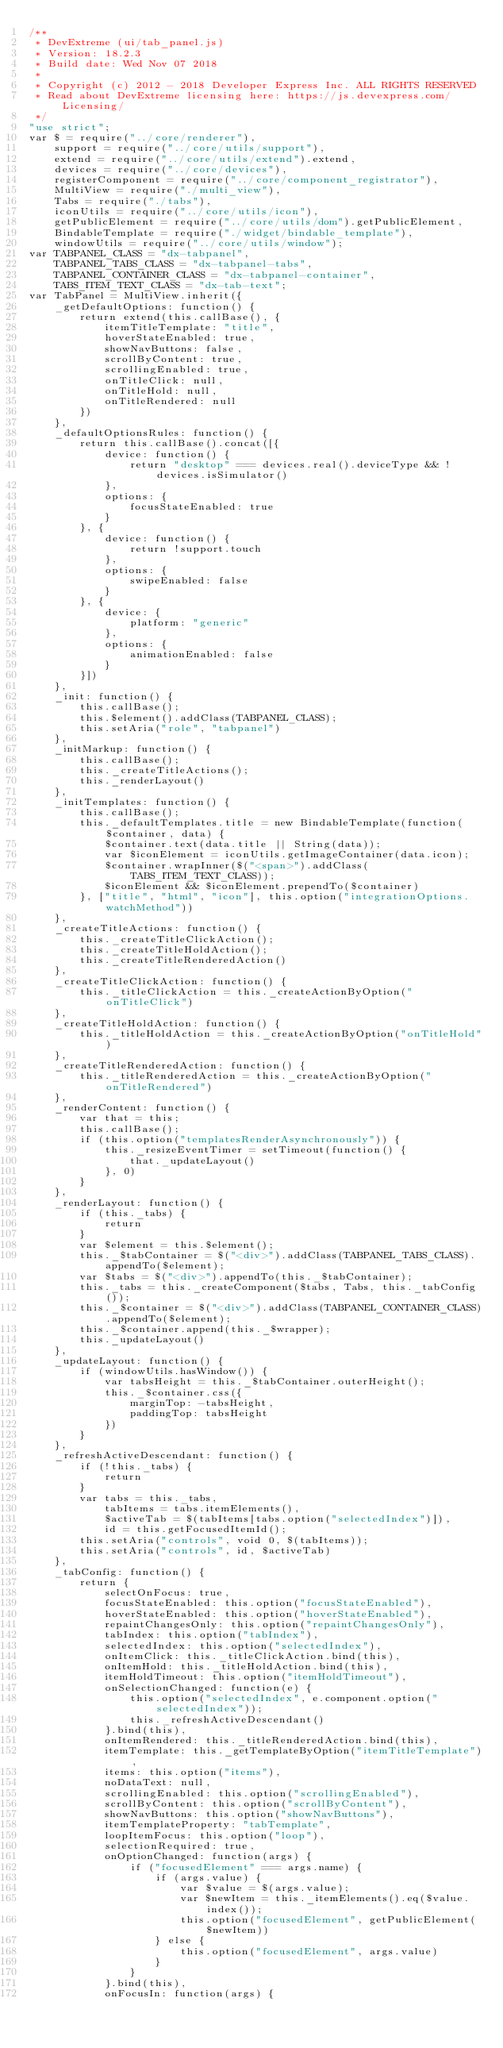Convert code to text. <code><loc_0><loc_0><loc_500><loc_500><_JavaScript_>/**
 * DevExtreme (ui/tab_panel.js)
 * Version: 18.2.3
 * Build date: Wed Nov 07 2018
 *
 * Copyright (c) 2012 - 2018 Developer Express Inc. ALL RIGHTS RESERVED
 * Read about DevExtreme licensing here: https://js.devexpress.com/Licensing/
 */
"use strict";
var $ = require("../core/renderer"),
    support = require("../core/utils/support"),
    extend = require("../core/utils/extend").extend,
    devices = require("../core/devices"),
    registerComponent = require("../core/component_registrator"),
    MultiView = require("./multi_view"),
    Tabs = require("./tabs"),
    iconUtils = require("../core/utils/icon"),
    getPublicElement = require("../core/utils/dom").getPublicElement,
    BindableTemplate = require("./widget/bindable_template"),
    windowUtils = require("../core/utils/window");
var TABPANEL_CLASS = "dx-tabpanel",
    TABPANEL_TABS_CLASS = "dx-tabpanel-tabs",
    TABPANEL_CONTAINER_CLASS = "dx-tabpanel-container",
    TABS_ITEM_TEXT_CLASS = "dx-tab-text";
var TabPanel = MultiView.inherit({
    _getDefaultOptions: function() {
        return extend(this.callBase(), {
            itemTitleTemplate: "title",
            hoverStateEnabled: true,
            showNavButtons: false,
            scrollByContent: true,
            scrollingEnabled: true,
            onTitleClick: null,
            onTitleHold: null,
            onTitleRendered: null
        })
    },
    _defaultOptionsRules: function() {
        return this.callBase().concat([{
            device: function() {
                return "desktop" === devices.real().deviceType && !devices.isSimulator()
            },
            options: {
                focusStateEnabled: true
            }
        }, {
            device: function() {
                return !support.touch
            },
            options: {
                swipeEnabled: false
            }
        }, {
            device: {
                platform: "generic"
            },
            options: {
                animationEnabled: false
            }
        }])
    },
    _init: function() {
        this.callBase();
        this.$element().addClass(TABPANEL_CLASS);
        this.setAria("role", "tabpanel")
    },
    _initMarkup: function() {
        this.callBase();
        this._createTitleActions();
        this._renderLayout()
    },
    _initTemplates: function() {
        this.callBase();
        this._defaultTemplates.title = new BindableTemplate(function($container, data) {
            $container.text(data.title || String(data));
            var $iconElement = iconUtils.getImageContainer(data.icon);
            $container.wrapInner($("<span>").addClass(TABS_ITEM_TEXT_CLASS));
            $iconElement && $iconElement.prependTo($container)
        }, ["title", "html", "icon"], this.option("integrationOptions.watchMethod"))
    },
    _createTitleActions: function() {
        this._createTitleClickAction();
        this._createTitleHoldAction();
        this._createTitleRenderedAction()
    },
    _createTitleClickAction: function() {
        this._titleClickAction = this._createActionByOption("onTitleClick")
    },
    _createTitleHoldAction: function() {
        this._titleHoldAction = this._createActionByOption("onTitleHold")
    },
    _createTitleRenderedAction: function() {
        this._titleRenderedAction = this._createActionByOption("onTitleRendered")
    },
    _renderContent: function() {
        var that = this;
        this.callBase();
        if (this.option("templatesRenderAsynchronously")) {
            this._resizeEventTimer = setTimeout(function() {
                that._updateLayout()
            }, 0)
        }
    },
    _renderLayout: function() {
        if (this._tabs) {
            return
        }
        var $element = this.$element();
        this._$tabContainer = $("<div>").addClass(TABPANEL_TABS_CLASS).appendTo($element);
        var $tabs = $("<div>").appendTo(this._$tabContainer);
        this._tabs = this._createComponent($tabs, Tabs, this._tabConfig());
        this._$container = $("<div>").addClass(TABPANEL_CONTAINER_CLASS).appendTo($element);
        this._$container.append(this._$wrapper);
        this._updateLayout()
    },
    _updateLayout: function() {
        if (windowUtils.hasWindow()) {
            var tabsHeight = this._$tabContainer.outerHeight();
            this._$container.css({
                marginTop: -tabsHeight,
                paddingTop: tabsHeight
            })
        }
    },
    _refreshActiveDescendant: function() {
        if (!this._tabs) {
            return
        }
        var tabs = this._tabs,
            tabItems = tabs.itemElements(),
            $activeTab = $(tabItems[tabs.option("selectedIndex")]),
            id = this.getFocusedItemId();
        this.setAria("controls", void 0, $(tabItems));
        this.setAria("controls", id, $activeTab)
    },
    _tabConfig: function() {
        return {
            selectOnFocus: true,
            focusStateEnabled: this.option("focusStateEnabled"),
            hoverStateEnabled: this.option("hoverStateEnabled"),
            repaintChangesOnly: this.option("repaintChangesOnly"),
            tabIndex: this.option("tabIndex"),
            selectedIndex: this.option("selectedIndex"),
            onItemClick: this._titleClickAction.bind(this),
            onItemHold: this._titleHoldAction.bind(this),
            itemHoldTimeout: this.option("itemHoldTimeout"),
            onSelectionChanged: function(e) {
                this.option("selectedIndex", e.component.option("selectedIndex"));
                this._refreshActiveDescendant()
            }.bind(this),
            onItemRendered: this._titleRenderedAction.bind(this),
            itemTemplate: this._getTemplateByOption("itemTitleTemplate"),
            items: this.option("items"),
            noDataText: null,
            scrollingEnabled: this.option("scrollingEnabled"),
            scrollByContent: this.option("scrollByContent"),
            showNavButtons: this.option("showNavButtons"),
            itemTemplateProperty: "tabTemplate",
            loopItemFocus: this.option("loop"),
            selectionRequired: true,
            onOptionChanged: function(args) {
                if ("focusedElement" === args.name) {
                    if (args.value) {
                        var $value = $(args.value);
                        var $newItem = this._itemElements().eq($value.index());
                        this.option("focusedElement", getPublicElement($newItem))
                    } else {
                        this.option("focusedElement", args.value)
                    }
                }
            }.bind(this),
            onFocusIn: function(args) {</code> 